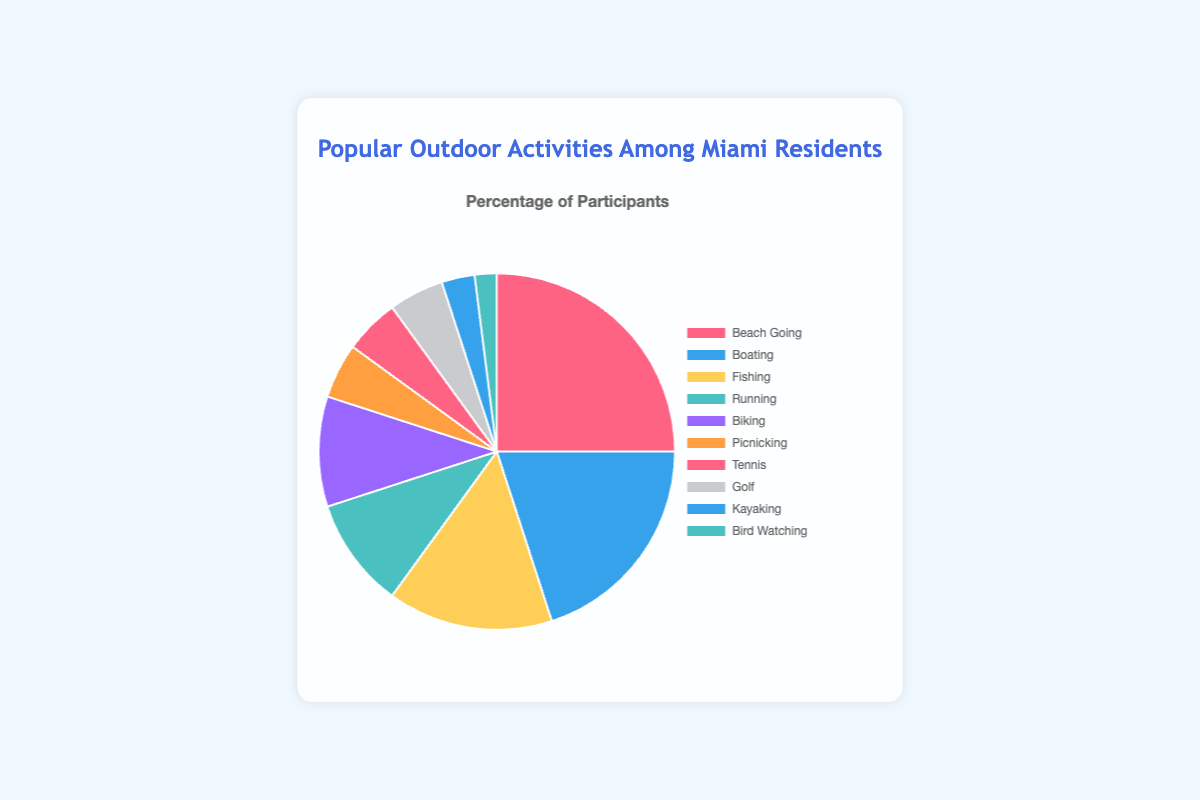Which activity has the highest percentage of participation? The activity with the highest percentage has a larger slice in the pie chart. Here, Beach Going has the largest slice.
Answer: Beach Going Which activities have an equal percentage of participation? Look for slices with the same size. Running and Biking both have 10%, Picnicking, Tennis, and Golf all have 5%.
Answer: Running and Biking; Picnicking, Tennis, and Golf What is the total percentage of those who participate in Boating and Kayaking? Sum the percentages for Boating (20%) and Kayaking (3%). 20% + 3% = 23%.
Answer: 23% How much higher is the percentage of people who go Beach Going compared to those who do Bird Watching? Subtract the percentage of Bird Watching (2%) from Beach Going (25%). 25% - 2% = 23%.
Answer: 23% Which two activities combined account for 30% of the total? Find activities whose individual percentages add up to 30%. Boating (20%) and Fishing (15%) give 35%, so that won’t work. Beach Going (25%) and Bird Watching (2%) don’t either. But Running (10%) + Biking (10%) + Picnicking (5%) + Tennis (5%) = 30%.
Answer: Running + Biking or Boating + Fishing What is the percentage difference between Fishing and Running? Subtract the percentage of Running (10%) from Fishing (15%). 15% - 10% = 5%.
Answer: 5% Which activity has the least percentage of participation? The smallest slice corresponds to the smallest percentage. Here, Bird Watching has the smallest slice.
Answer: Bird Watching If the percentage of people who go Boating increases by 5%, what would Boating rank in comparison to Beach Going? Adding 5% to Boating makes it 25%, equal to Beach Going. They would both rank as the highest.
Answer: Equal to Beach Going Which activity has a higher percentage, Tennis or Kayaking? Compare the slices for Tennis (5%) and Kayaking (3%).
Answer: Tennis (5%) is higher than Kayaking (3%) What color represents the activity of Fishing? Identify the color associated with the label "Fishing" on the pie chart. Fishing is represented by yellow (#FFCE56).
Answer: Yellow 